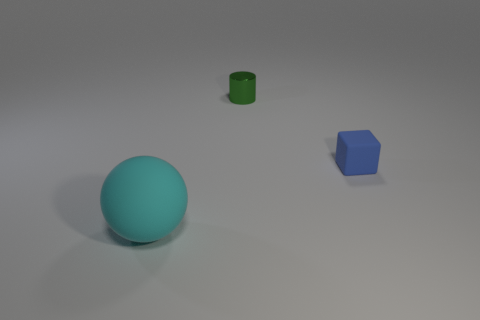There is a ball; are there any tiny rubber blocks to the left of it?
Provide a succinct answer. No. How many objects are either tiny green metal cylinders or things that are behind the rubber block?
Your response must be concise. 1. Are there any tiny shiny objects that are in front of the rubber thing that is to the left of the tiny cube?
Your answer should be compact. No. The green metallic thing behind the tiny thing that is right of the object behind the blue matte thing is what shape?
Your answer should be very brief. Cylinder. There is a object that is to the left of the tiny blue object and in front of the small green cylinder; what is its color?
Ensure brevity in your answer.  Cyan. There is a rubber thing that is right of the green metallic cylinder; what shape is it?
Offer a very short reply. Cube. There is a cyan object that is the same material as the blue object; what shape is it?
Provide a succinct answer. Sphere. What number of matte things are brown cylinders or cylinders?
Offer a very short reply. 0. How many tiny blue matte things are in front of the rubber thing that is in front of the rubber object that is on the right side of the tiny green shiny cylinder?
Your response must be concise. 0. Does the matte thing on the right side of the green cylinder have the same size as the thing behind the small matte cube?
Your answer should be very brief. Yes. 